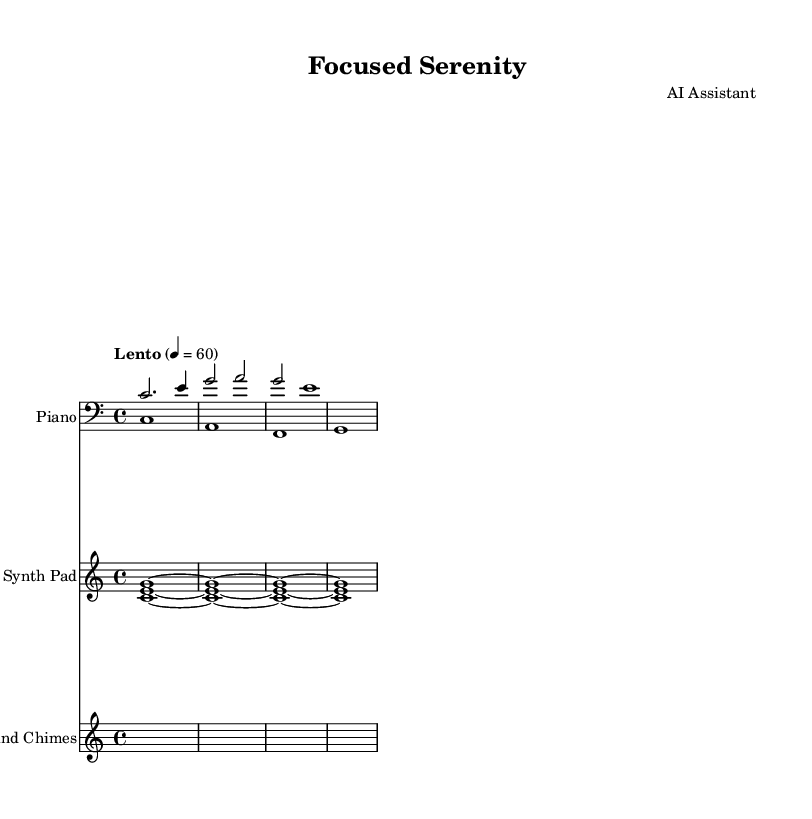What is the key signature of this music? The key signature is indicated at the beginning of the sheet music and shows there are no sharps or flats, confirming it is in C major.
Answer: C major What is the time signature of this music? The time signature is found at the beginning of the sheet music; it shows that the music is in 4/4 time, meaning there are four beats in each measure.
Answer: 4/4 What is the tempo marking of this piece? The tempo marking, also found near the start of the music, indicates that the piece should be played at Lento, which is a slow tempo, with a metronome marking of 60 beats per minute.
Answer: Lento How many measures does the right hand piano part have? By looking at the right hand piano part, you can count the measures. It contains three measures in total, as indicated by the segment dividers in the music.
Answer: 3 What instruments are used in this score? The score has three distinct staves indicating the instruments: one for Piano, one for Synth Pad, and one for Wind Chimes, showing a variety of sounds contributing to the ambient soundscape.
Answer: Piano, Synth Pad, Wind Chimes Which chord is played by the synth pad? The synth pad staff shows a sustained chord consisting of the notes C, E, and G, played together, which identifies it as a C major chord played throughout the measures.
Answer: C major chord 